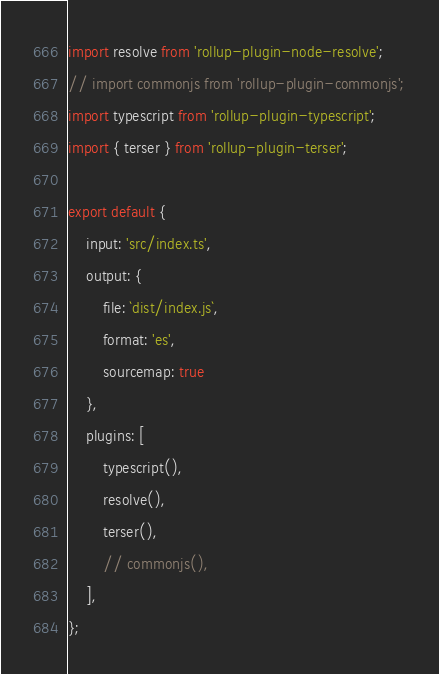Convert code to text. <code><loc_0><loc_0><loc_500><loc_500><_JavaScript_>import resolve from 'rollup-plugin-node-resolve';
// import commonjs from 'rollup-plugin-commonjs';
import typescript from 'rollup-plugin-typescript';
import { terser } from 'rollup-plugin-terser';

export default {
    input: 'src/index.ts',
    output: {
        file: `dist/index.js`,
        format: 'es',
        sourcemap: true
    },
    plugins: [
        typescript(),
        resolve(),
        terser(),
        // commonjs(),
    ],
};</code> 